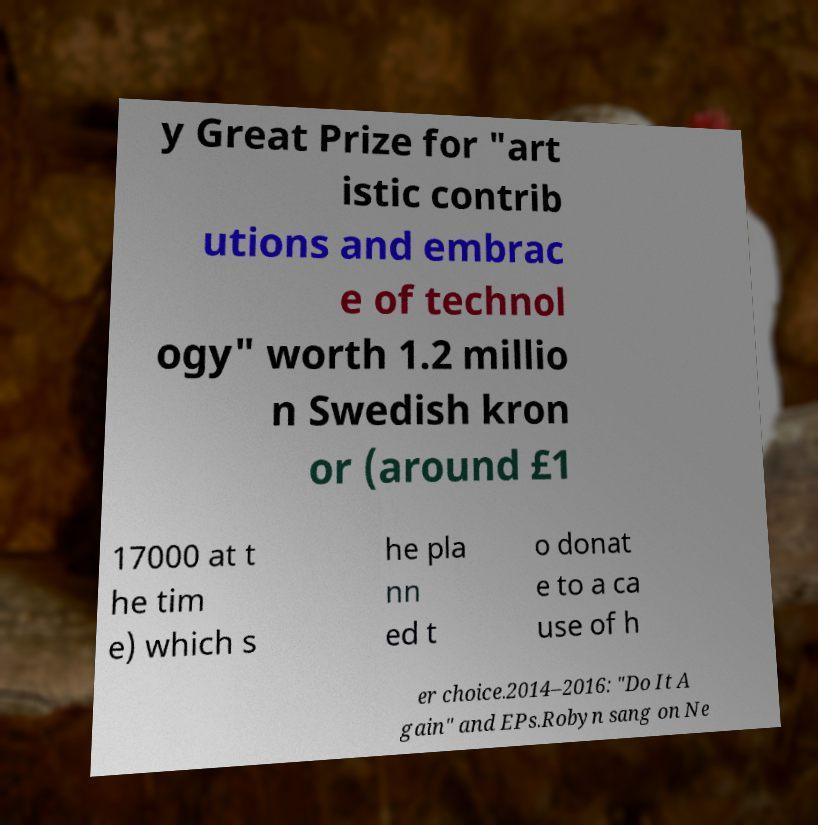What messages or text are displayed in this image? I need them in a readable, typed format. y Great Prize for "art istic contrib utions and embrac e of technol ogy" worth 1.2 millio n Swedish kron or (around £1 17000 at t he tim e) which s he pla nn ed t o donat e to a ca use of h er choice.2014–2016: "Do It A gain" and EPs.Robyn sang on Ne 